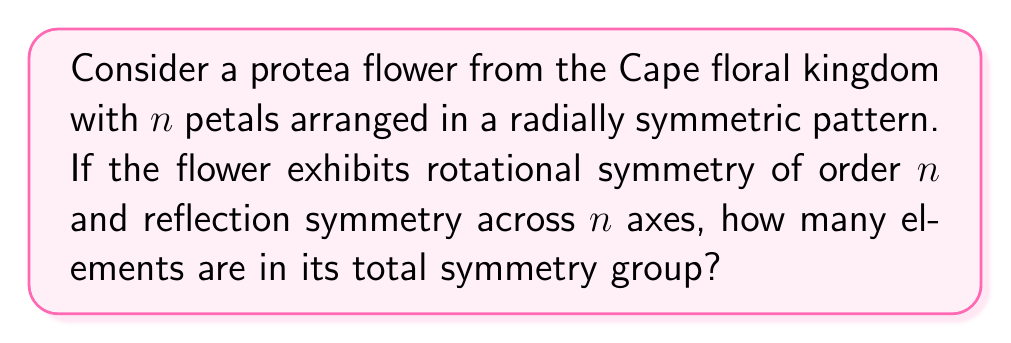What is the answer to this math problem? Let's approach this step-by-step:

1) First, we need to identify the symmetry operations:
   - Rotational symmetry of order $n$
   - Reflection symmetry across $n$ axes

2) For rotational symmetry:
   - There are $n$ rotations possible, including the identity rotation (360°)
   - These rotations are: $\frac{360°}{n}, \frac{2 \cdot 360°}{n}, ..., \frac{(n-1) \cdot 360°}{n}, 360°$

3) For reflection symmetry:
   - There are $n$ reflection axes

4) The total number of symmetry operations is the sum of:
   - $n$ rotations
   - $n$ reflections

5) Therefore, the total number of elements in the symmetry group is:
   $$ \text{Total elements} = n + n = 2n $$

6) This symmetry group is known as the dihedral group $D_n$, which has order $2n$.
Answer: $2n$ 